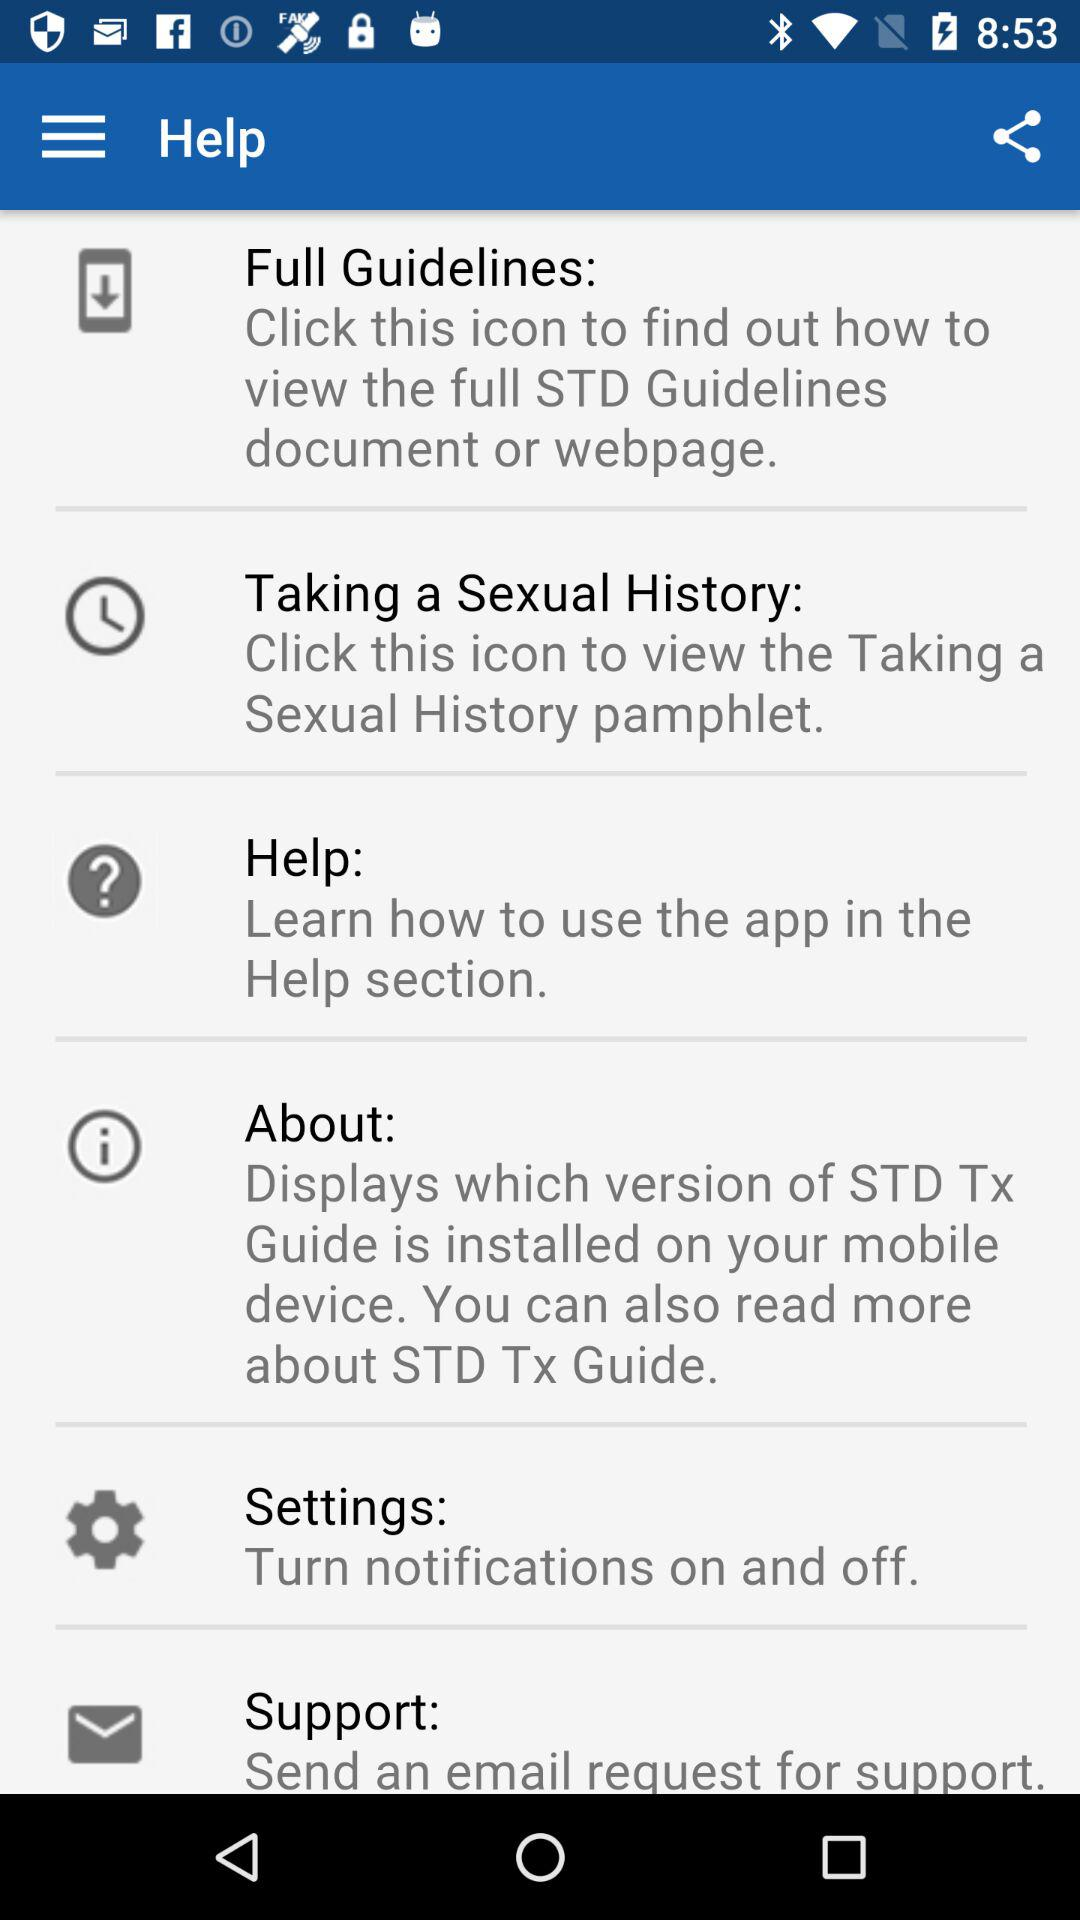How many notifications are there in "Settings"?
When the provided information is insufficient, respond with <no answer>. <no answer> 